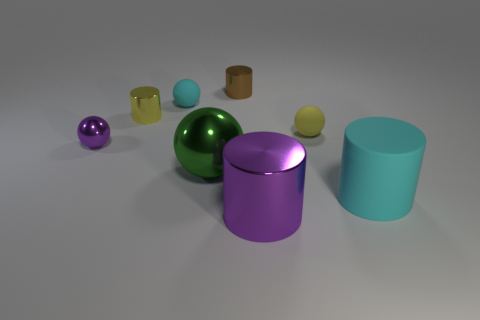Can you describe the texture of the objects in the image? Certainly! The objects in the image exhibit smooth textures with a shiny, reflective quality that suggests a polished finish, likely indicative of materials like plastic, metal, or glass. 